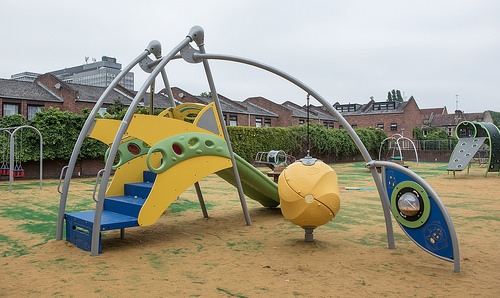<image>
Is there a leaf on the stairs? Yes. Looking at the image, I can see the leaf is positioned on top of the stairs, with the stairs providing support. 